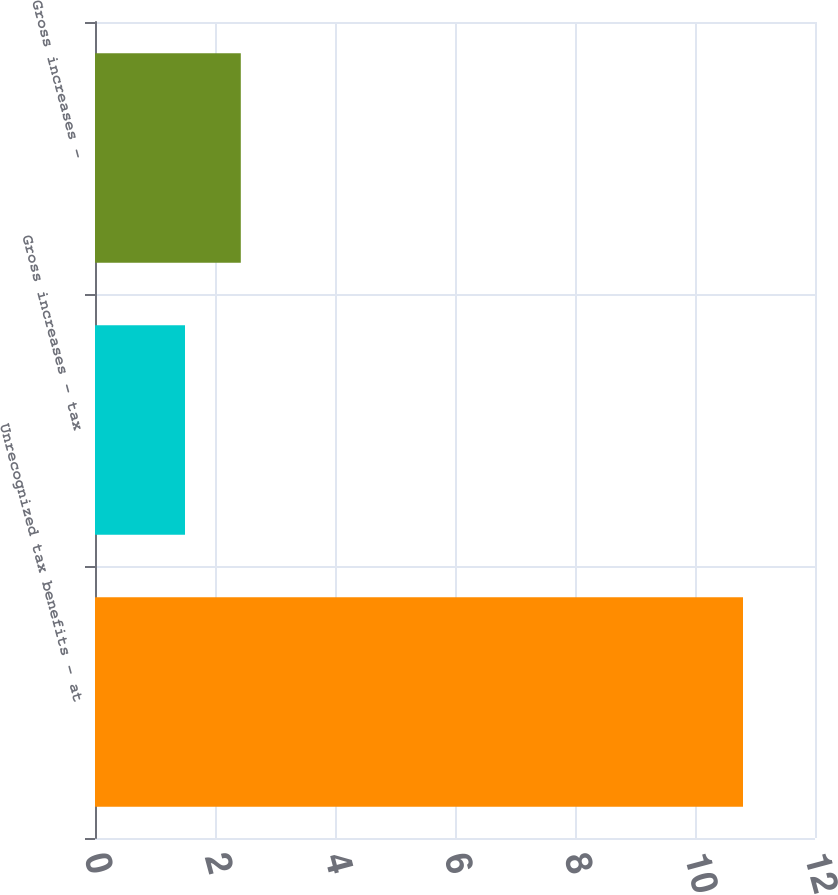Convert chart to OTSL. <chart><loc_0><loc_0><loc_500><loc_500><bar_chart><fcel>Unrecognized tax benefits - at<fcel>Gross increases - tax<fcel>Gross increases -<nl><fcel>10.8<fcel>1.5<fcel>2.43<nl></chart> 